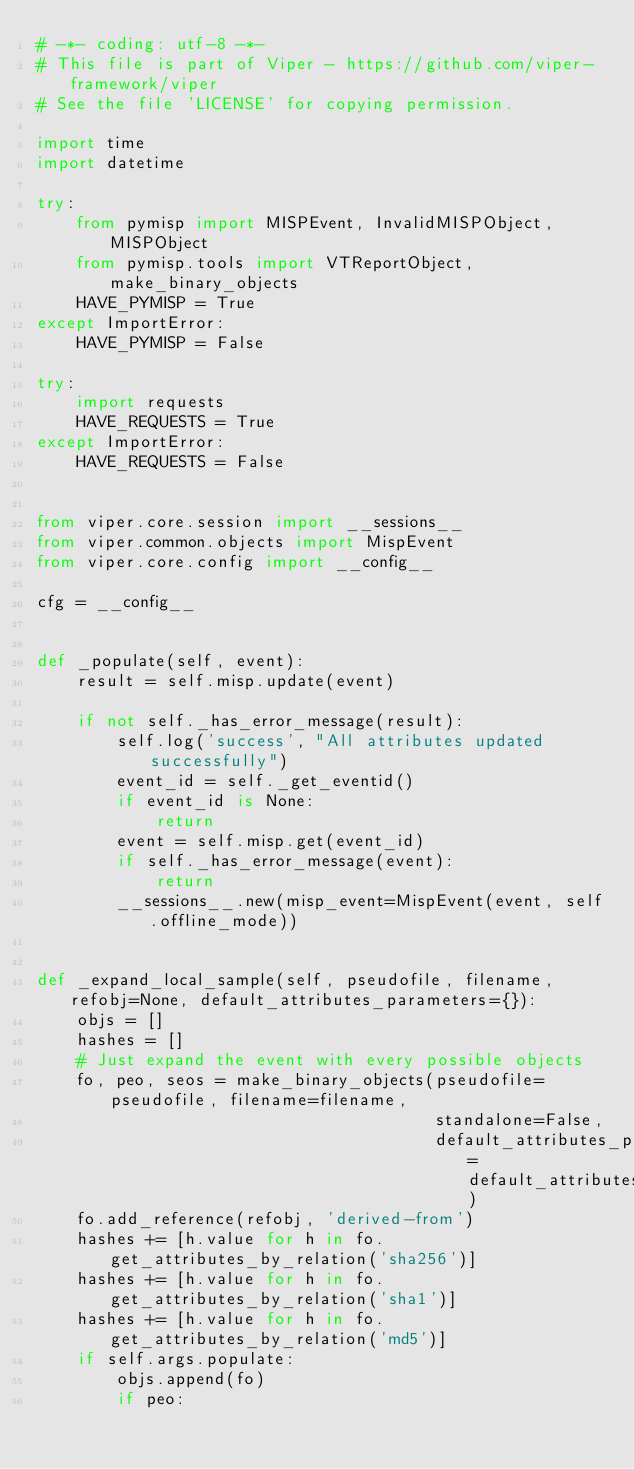<code> <loc_0><loc_0><loc_500><loc_500><_Python_># -*- coding: utf-8 -*-
# This file is part of Viper - https://github.com/viper-framework/viper
# See the file 'LICENSE' for copying permission.

import time
import datetime

try:
    from pymisp import MISPEvent, InvalidMISPObject, MISPObject
    from pymisp.tools import VTReportObject, make_binary_objects
    HAVE_PYMISP = True
except ImportError:
    HAVE_PYMISP = False

try:
    import requests
    HAVE_REQUESTS = True
except ImportError:
    HAVE_REQUESTS = False


from viper.core.session import __sessions__
from viper.common.objects import MispEvent
from viper.core.config import __config__

cfg = __config__


def _populate(self, event):
    result = self.misp.update(event)

    if not self._has_error_message(result):
        self.log('success', "All attributes updated successfully")
        event_id = self._get_eventid()
        if event_id is None:
            return
        event = self.misp.get(event_id)
        if self._has_error_message(event):
            return
        __sessions__.new(misp_event=MispEvent(event, self.offline_mode))


def _expand_local_sample(self, pseudofile, filename, refobj=None, default_attributes_parameters={}):
    objs = []
    hashes = []
    # Just expand the event with every possible objects
    fo, peo, seos = make_binary_objects(pseudofile=pseudofile, filename=filename,
                                        standalone=False,
                                        default_attributes_parameters=default_attributes_parameters)
    fo.add_reference(refobj, 'derived-from')
    hashes += [h.value for h in fo.get_attributes_by_relation('sha256')]
    hashes += [h.value for h in fo.get_attributes_by_relation('sha1')]
    hashes += [h.value for h in fo.get_attributes_by_relation('md5')]
    if self.args.populate:
        objs.append(fo)
        if peo:</code> 